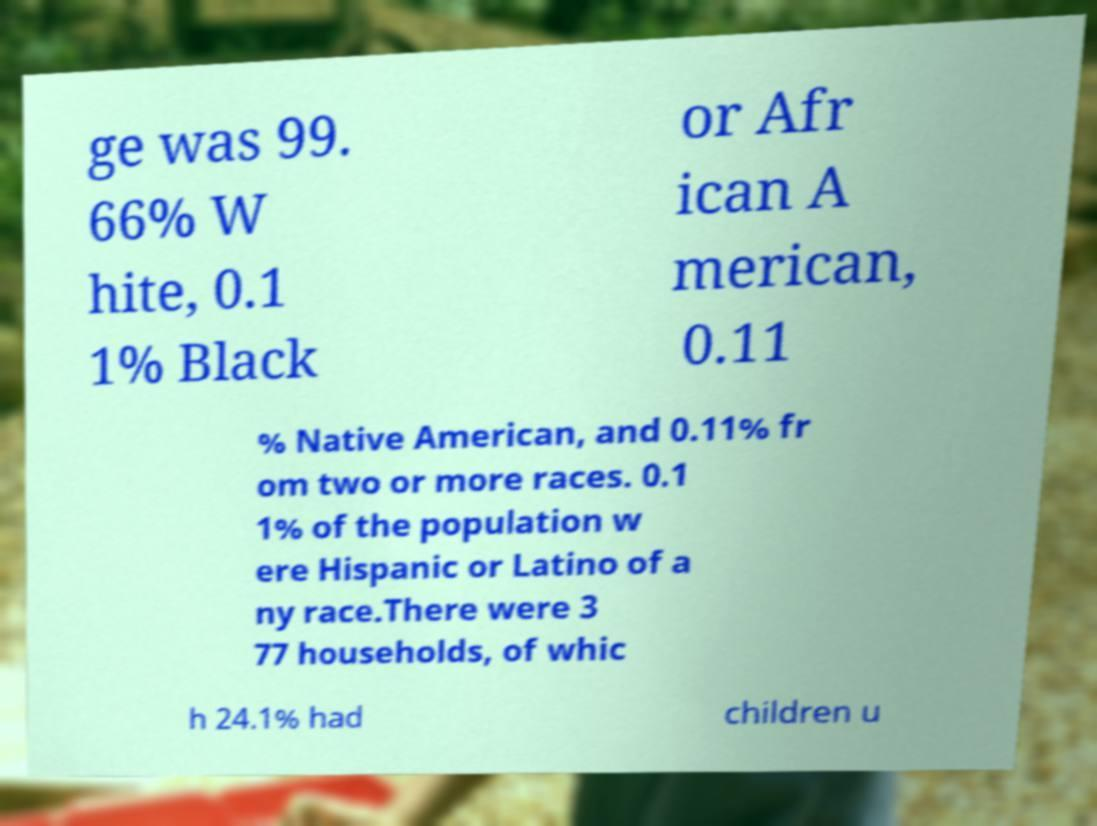Please identify and transcribe the text found in this image. ge was 99. 66% W hite, 0.1 1% Black or Afr ican A merican, 0.11 % Native American, and 0.11% fr om two or more races. 0.1 1% of the population w ere Hispanic or Latino of a ny race.There were 3 77 households, of whic h 24.1% had children u 